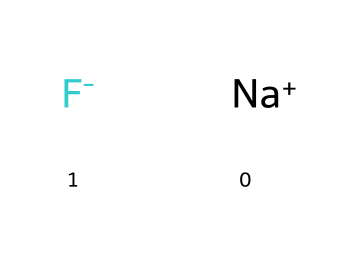What ions are present in this chemical? The chemical displays sodium as Na+ and fluorine as F-, indicating the presence of these two ions.
Answer: sodium and fluorine How many total atoms are in this compound? The compound consists of two ions: one sodium ion and one fluorine ion. Thus, the total number of atoms is two.
Answer: two What type of chemical bond is formed between sodium and fluorine? Sodium (Na+) loses an electron to become positively charged, while fluorine (F-) gains an electron to become negatively charged, leading to an ionic bond between them.
Answer: ionic bond What role does fluorine play in dental hygiene? Fluorine is known for its ability to strengthen tooth enamel and prevent cavities, making it a crucial additive in toothpaste for dental hygiene.
Answer: strengthen enamel What is the charge of the fluorine ion in this compound? The fluorine ion is indicated as F- in the chemical representation, which shows that it has a negative charge.
Answer: negative Why is sodium included alongside fluorine in this chemical? Sodium serves to balance the charge of the fluoride ion, creating a neutral compound where the overall charge is zero.
Answer: to balance charge 